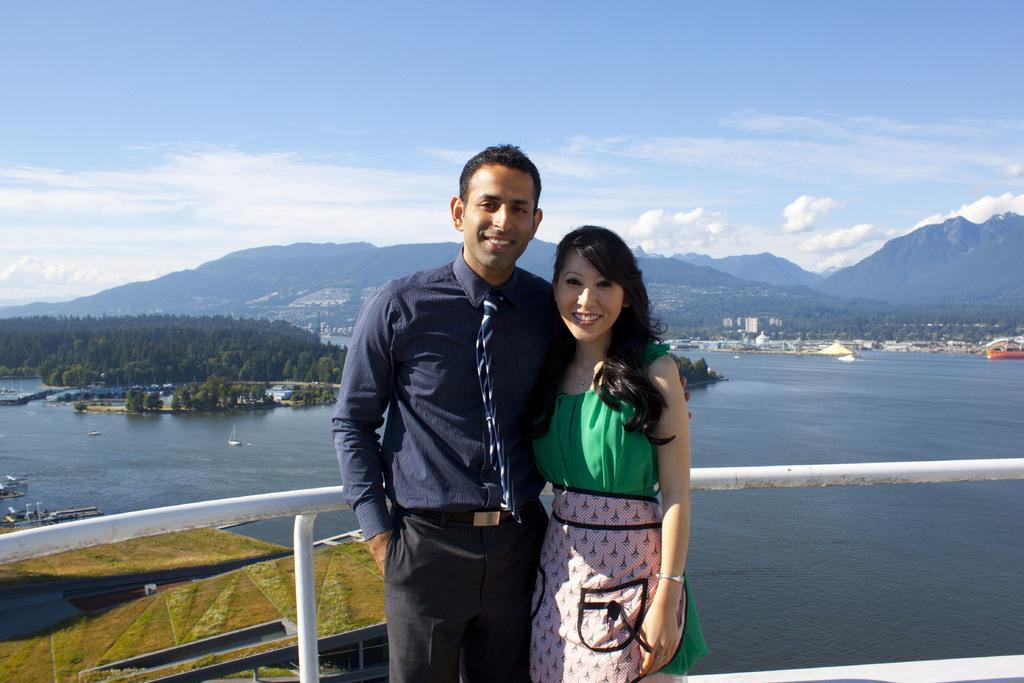Describe this image in one or two sentences. In the center of the image, we can see a man and a lady standing and there is a railing. In the background, there are boats on the water and we can see trees, hills, buildings and tents. At the top, there are clouds in the sky. 